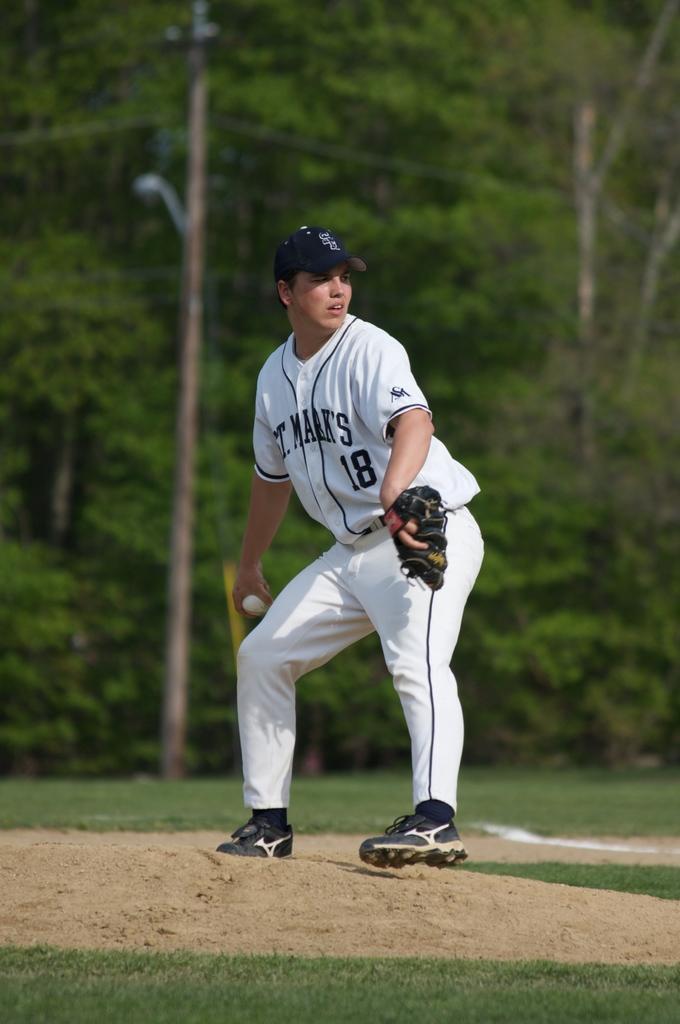In one or two sentences, can you explain what this image depicts? In this image there is men he is wearing blue color cap, white color T-shirt, pant and black color shoes, holding gloves and a ball in his hand standing on the ground, in the background there are trees. 